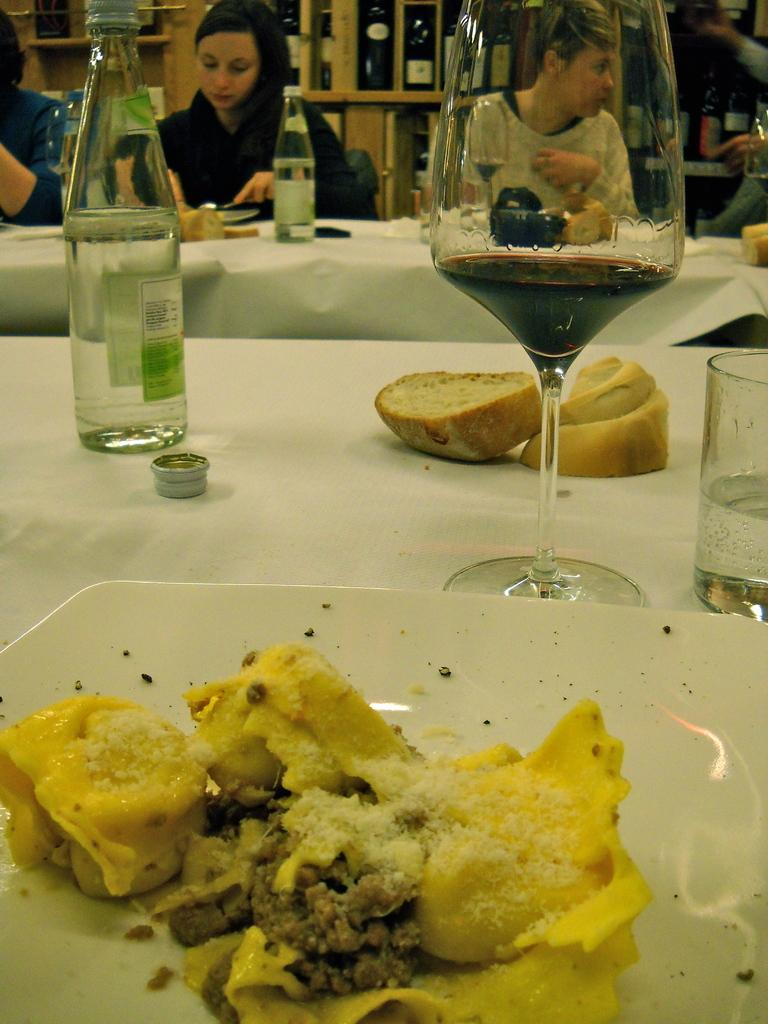What piece of furniture is present in the image? There is a table in the image. What objects are placed on the table? There are glasses, bottles, and plates with food on the table. What might the people sitting on chairs be doing? The people sitting on chairs might be eating or socializing. Can you describe the table setting in the image? The table setting includes glasses, bottles, and plates with food. What type of silk fabric is draped over the chairs in the image? There is no silk fabric present in the image; the chairs are occupied by people. 